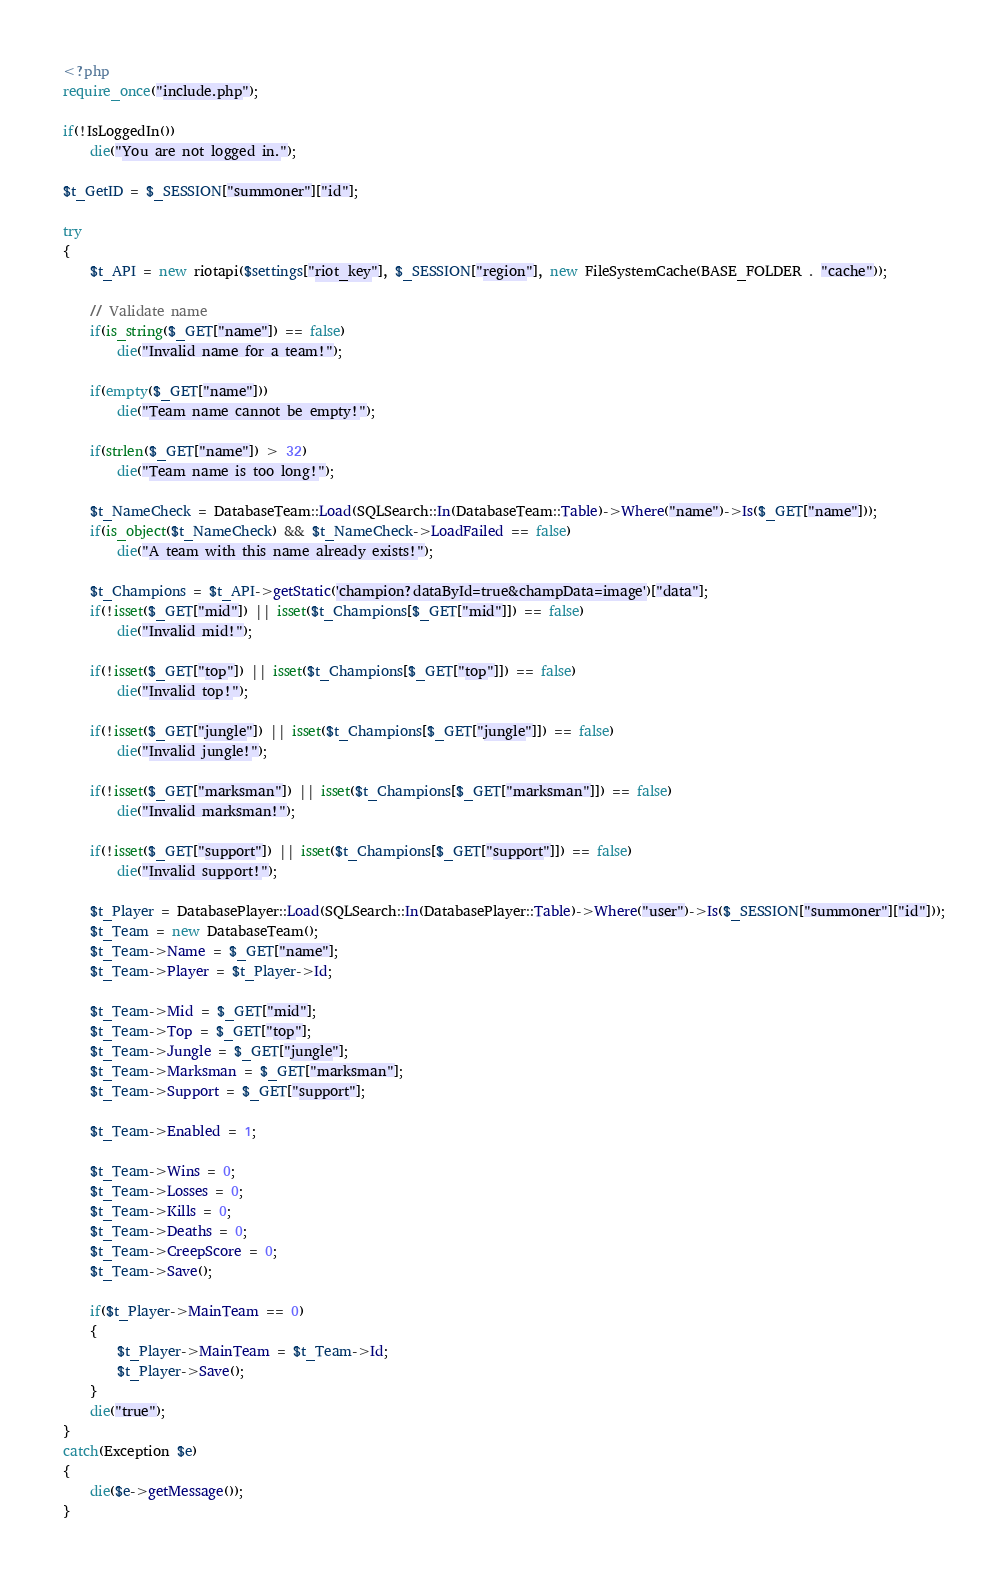<code> <loc_0><loc_0><loc_500><loc_500><_PHP_><?php
require_once("include.php");

if(!IsLoggedIn())
	die("You are not logged in.");

$t_GetID = $_SESSION["summoner"]["id"];

try
{
	$t_API = new riotapi($settings["riot_key"], $_SESSION["region"], new FileSystemCache(BASE_FOLDER . "cache"));

	// Validate name
	if(is_string($_GET["name"]) == false)
		die("Invalid name for a team!");

	if(empty($_GET["name"]))
		die("Team name cannot be empty!");
	
	if(strlen($_GET["name"]) > 32)
		die("Team name is too long!");
	
	$t_NameCheck = DatabaseTeam::Load(SQLSearch::In(DatabaseTeam::Table)->Where("name")->Is($_GET["name"]));
	if(is_object($t_NameCheck) && $t_NameCheck->LoadFailed == false)
		die("A team with this name already exists!");

	$t_Champions = $t_API->getStatic('champion?dataById=true&champData=image')["data"];
	if(!isset($_GET["mid"]) || isset($t_Champions[$_GET["mid"]]) == false)
		die("Invalid mid!");
	
	if(!isset($_GET["top"]) || isset($t_Champions[$_GET["top"]]) == false)
		die("Invalid top!");
	
	if(!isset($_GET["jungle"]) || isset($t_Champions[$_GET["jungle"]]) == false)
		die("Invalid jungle!");
	
	if(!isset($_GET["marksman"]) || isset($t_Champions[$_GET["marksman"]]) == false)
		die("Invalid marksman!");
	
	if(!isset($_GET["support"]) || isset($t_Champions[$_GET["support"]]) == false)
		die("Invalid support!");
	
	$t_Player = DatabasePlayer::Load(SQLSearch::In(DatabasePlayer::Table)->Where("user")->Is($_SESSION["summoner"]["id"]));
	$t_Team = new DatabaseTeam();
	$t_Team->Name = $_GET["name"];
	$t_Team->Player = $t_Player->Id;
	
	$t_Team->Mid = $_GET["mid"];
	$t_Team->Top = $_GET["top"];
	$t_Team->Jungle = $_GET["jungle"];
	$t_Team->Marksman = $_GET["marksman"];
	$t_Team->Support = $_GET["support"];
	
	$t_Team->Enabled = 1;
	
	$t_Team->Wins = 0;
	$t_Team->Losses = 0;
	$t_Team->Kills = 0;
	$t_Team->Deaths = 0;
	$t_Team->CreepScore = 0;
	$t_Team->Save();

	if($t_Player->MainTeam == 0)
	{
		$t_Player->MainTeam = $t_Team->Id;
		$t_Player->Save();
	}
	die("true");
}
catch(Exception $e)
{
	die($e->getMessage());
}
</code> 